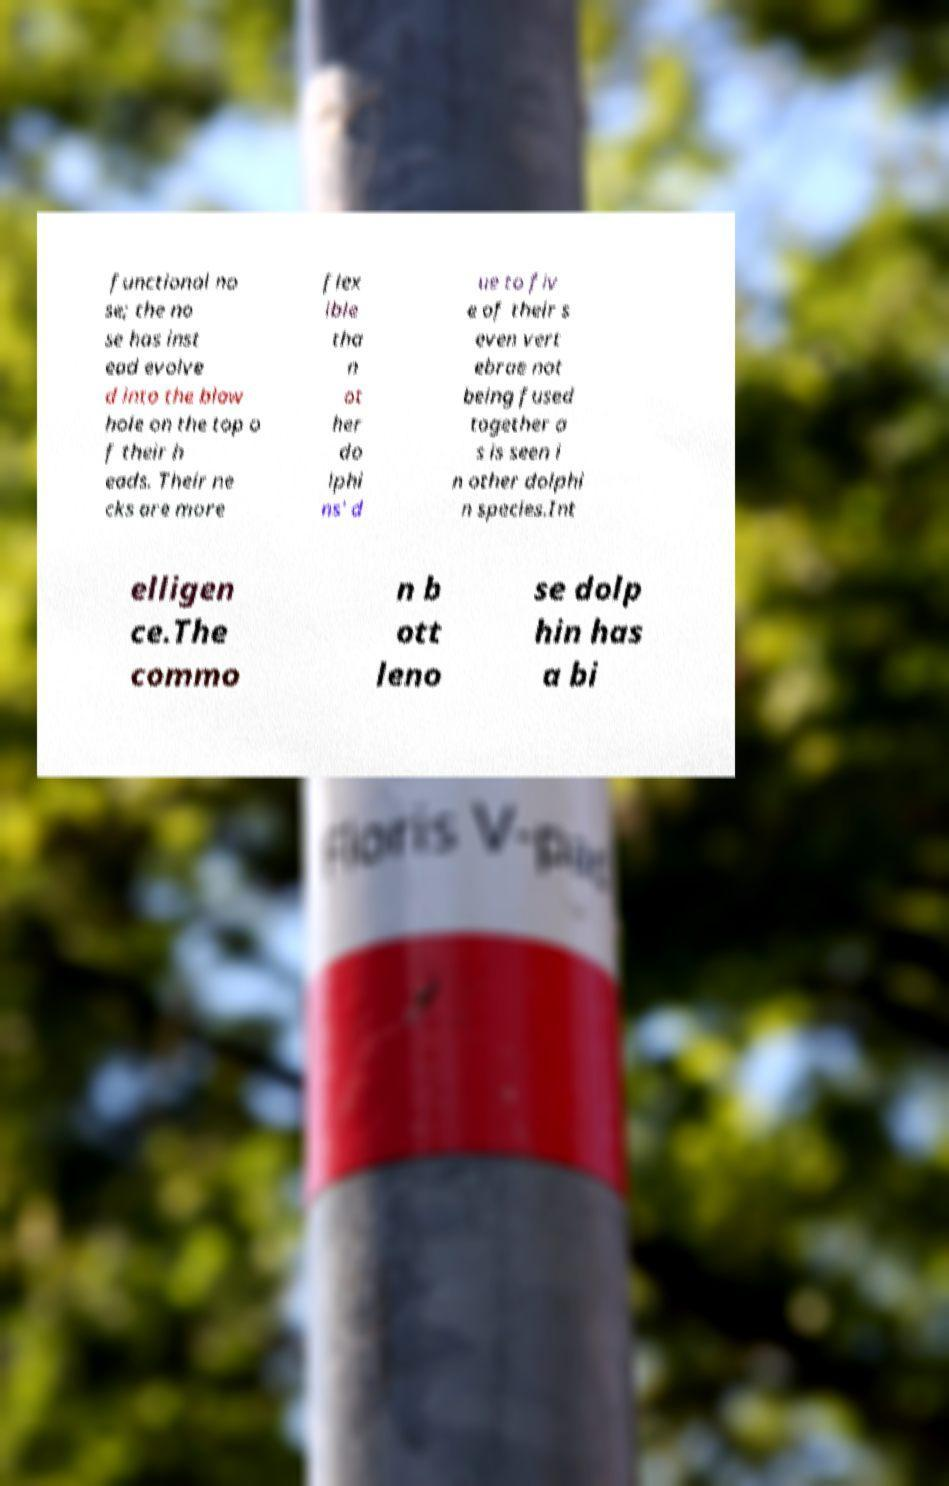What messages or text are displayed in this image? I need them in a readable, typed format. functional no se; the no se has inst ead evolve d into the blow hole on the top o f their h eads. Their ne cks are more flex ible tha n ot her do lphi ns' d ue to fiv e of their s even vert ebrae not being fused together a s is seen i n other dolphi n species.Int elligen ce.The commo n b ott leno se dolp hin has a bi 